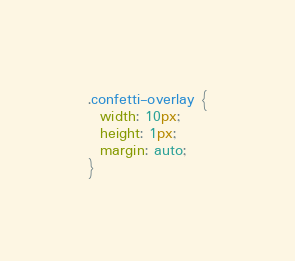<code> <loc_0><loc_0><loc_500><loc_500><_CSS_>.confetti-overlay {
  width: 10px;
  height: 1px;
  margin: auto;
}
</code> 